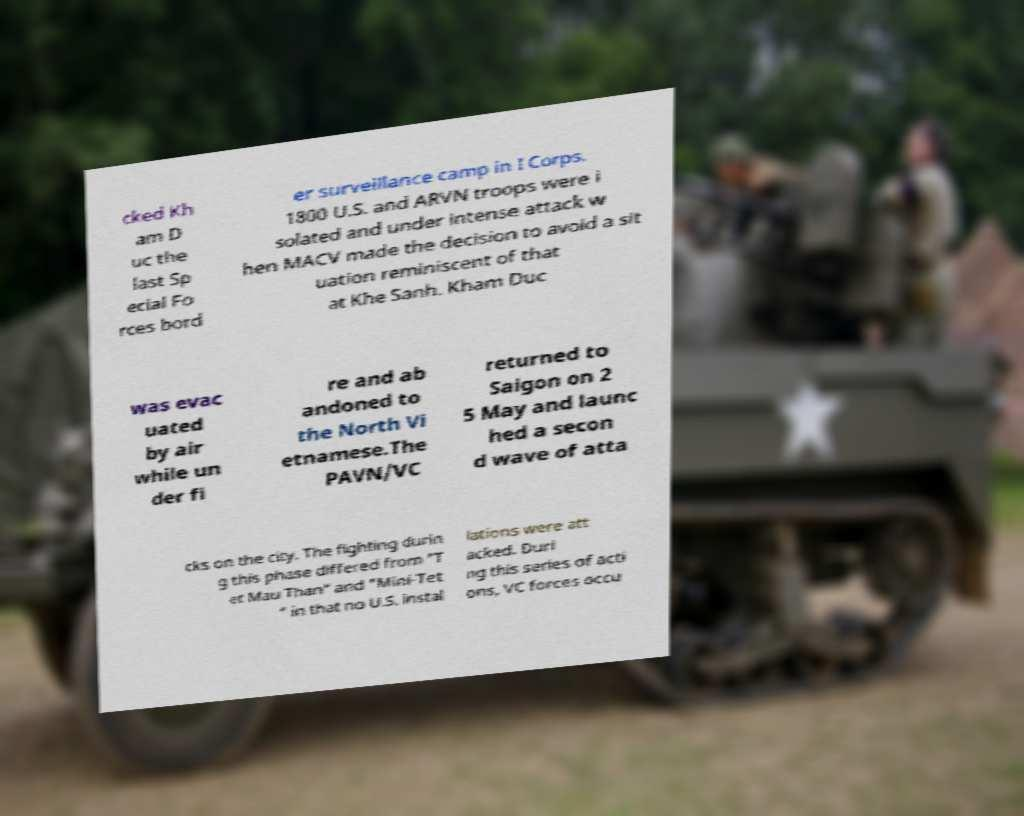What messages or text are displayed in this image? I need them in a readable, typed format. cked Kh am D uc the last Sp ecial Fo rces bord er surveillance camp in I Corps. 1800 U.S. and ARVN troops were i solated and under intense attack w hen MACV made the decision to avoid a sit uation reminiscent of that at Khe Sanh. Kham Duc was evac uated by air while un der fi re and ab andoned to the North Vi etnamese.The PAVN/VC returned to Saigon on 2 5 May and launc hed a secon d wave of atta cks on the city. The fighting durin g this phase differed from "T et Mau Than" and "Mini-Tet " in that no U.S. instal lations were att acked. Duri ng this series of acti ons, VC forces occu 